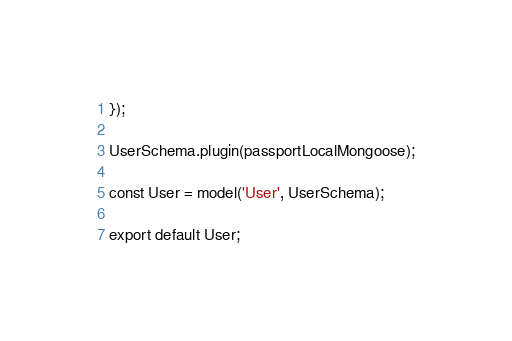<code> <loc_0><loc_0><loc_500><loc_500><_JavaScript_>});

UserSchema.plugin(passportLocalMongoose);

const User = model('User', UserSchema);

export default User;
</code> 